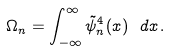Convert formula to latex. <formula><loc_0><loc_0><loc_500><loc_500>\Omega _ { n } = \int _ { - \infty } ^ { \infty } \tilde { \psi } _ { n } ^ { 4 } ( x ) \ d x \, .</formula> 